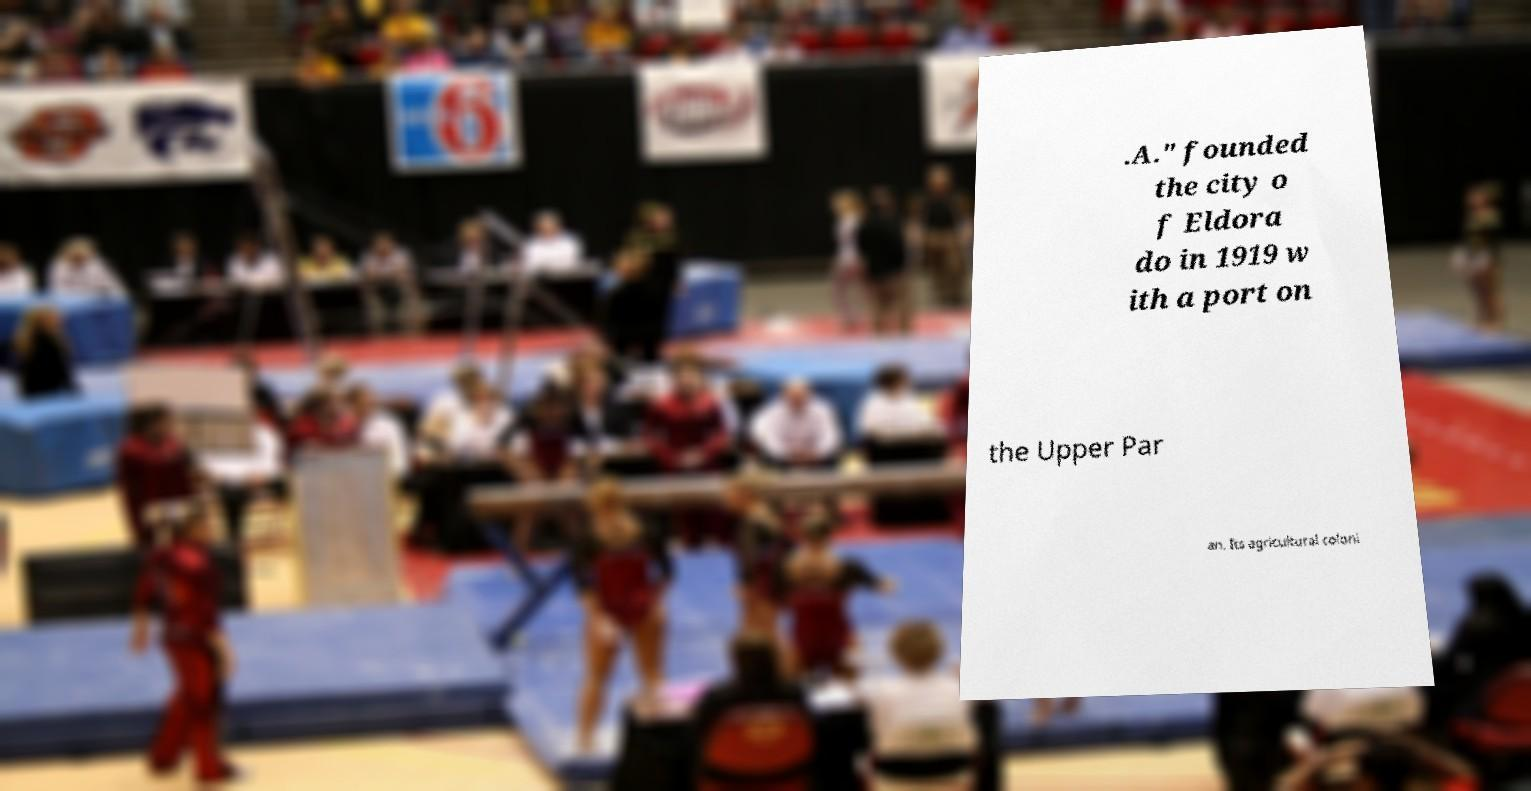Could you extract and type out the text from this image? .A." founded the city o f Eldora do in 1919 w ith a port on the Upper Par an. Its agricultural coloni 